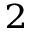Convert formula to latex. <formula><loc_0><loc_0><loc_500><loc_500>^ { 2 }</formula> 